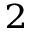Convert formula to latex. <formula><loc_0><loc_0><loc_500><loc_500>^ { 2 }</formula> 